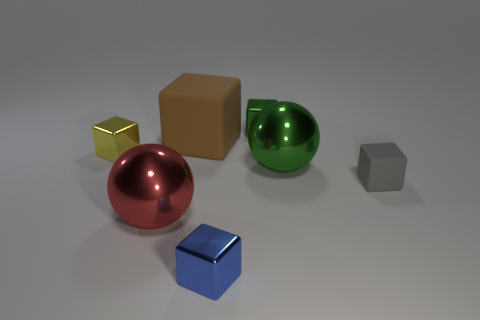How many objects in the image are perfectly reflective? The two spherical objects, one red and one green, appear to have perfectly reflective surfaces based on the light and environment reflections visible on them.  What colors are the objects, and do any of them share the same color? The objects in the image are colored as follows: one red sphere, one green sphere, one brown cube, one silver cube, and one blue rhombicuboctahedron. None of the objects share the exact same color. 